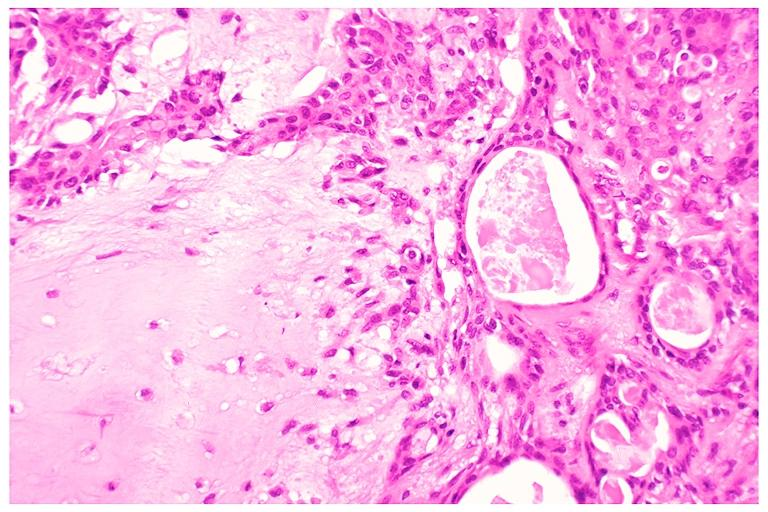s postpartum uterus present?
Answer the question using a single word or phrase. No 